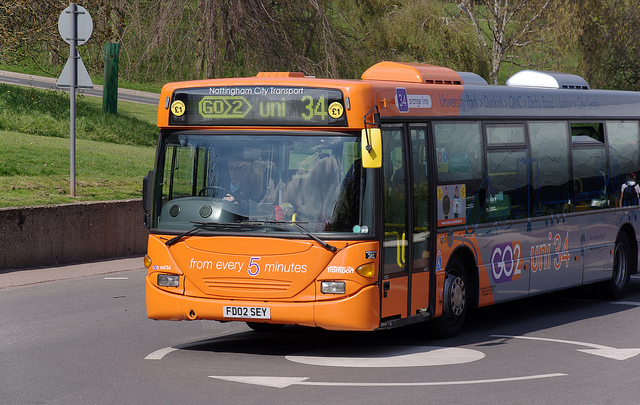Please transcribe the text in this image. 5 minutes from every F002 